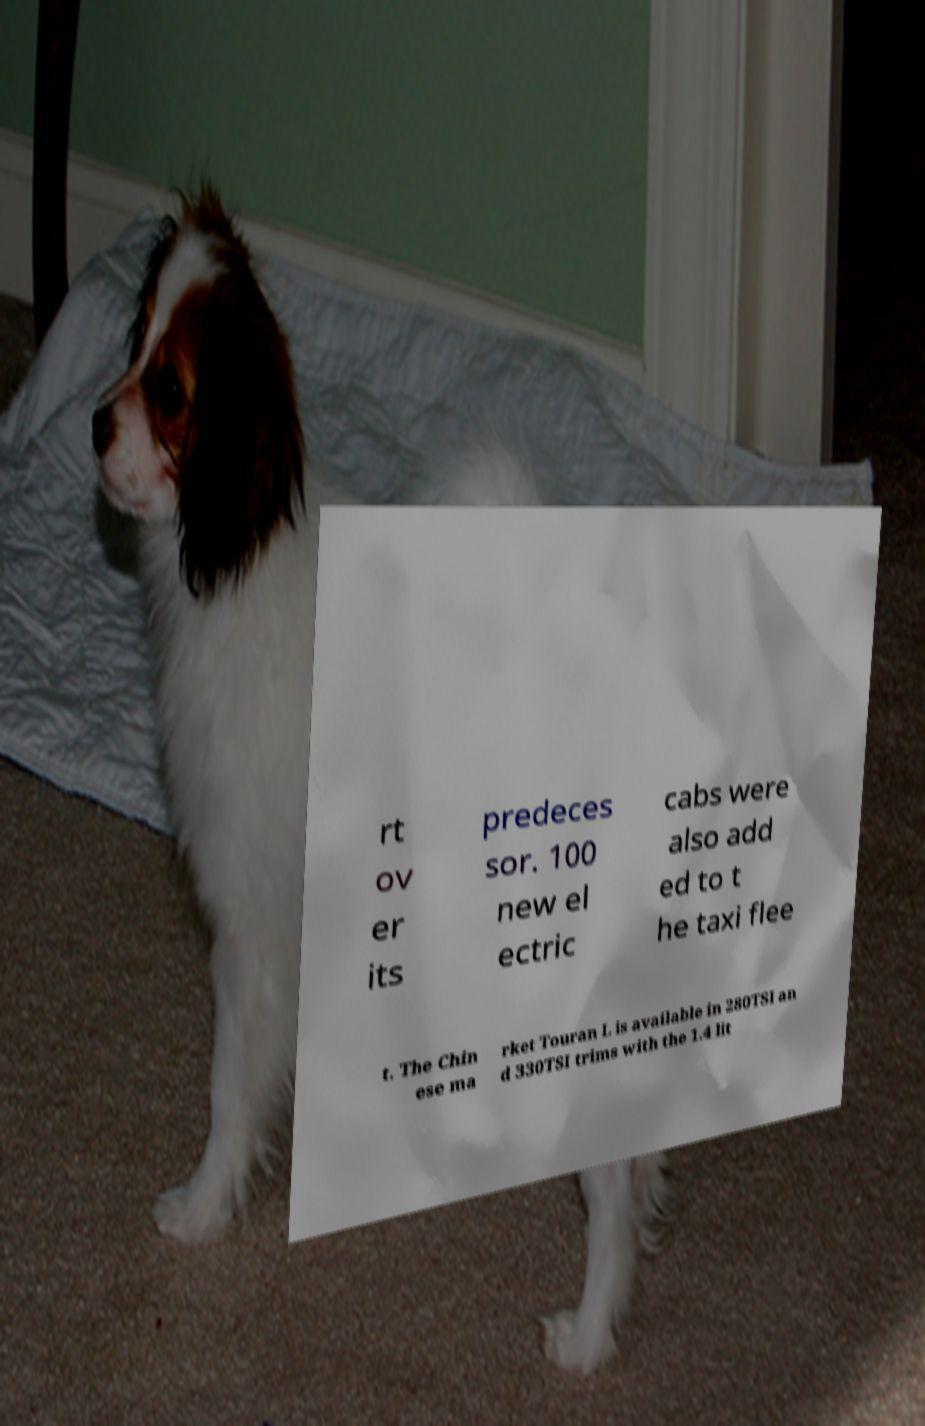Can you accurately transcribe the text from the provided image for me? rt ov er its predeces sor. 100 new el ectric cabs were also add ed to t he taxi flee t. The Chin ese ma rket Touran L is available in 280TSI an d 330TSI trims with the 1.4 lit 